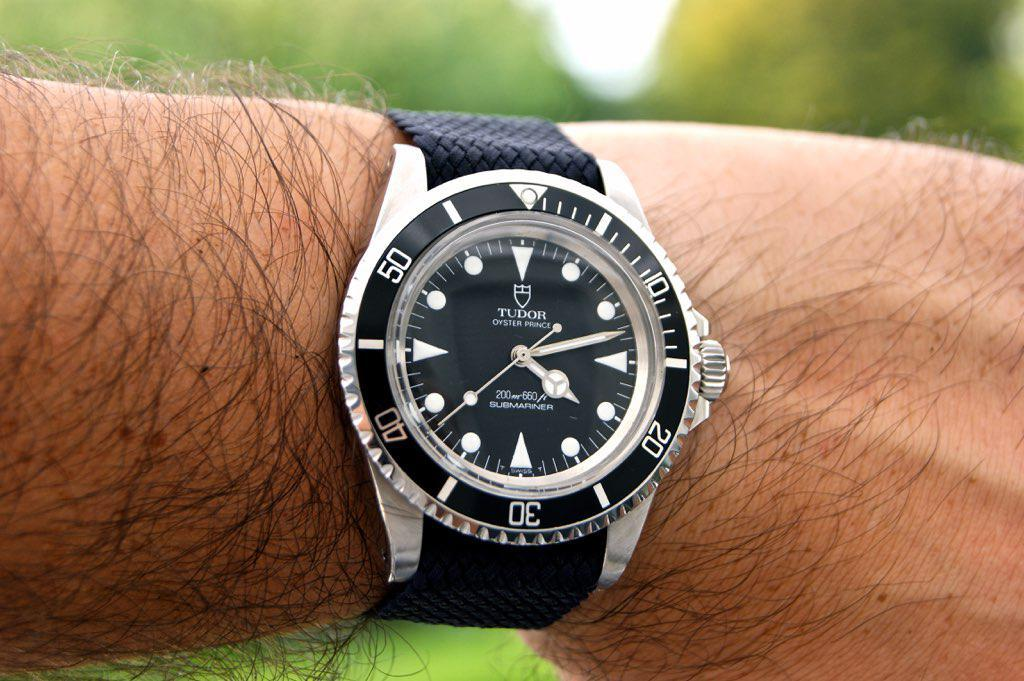Provide a one-sentence caption for the provided image. A Tudor Submariner brand watch, model Oyster Prince. 